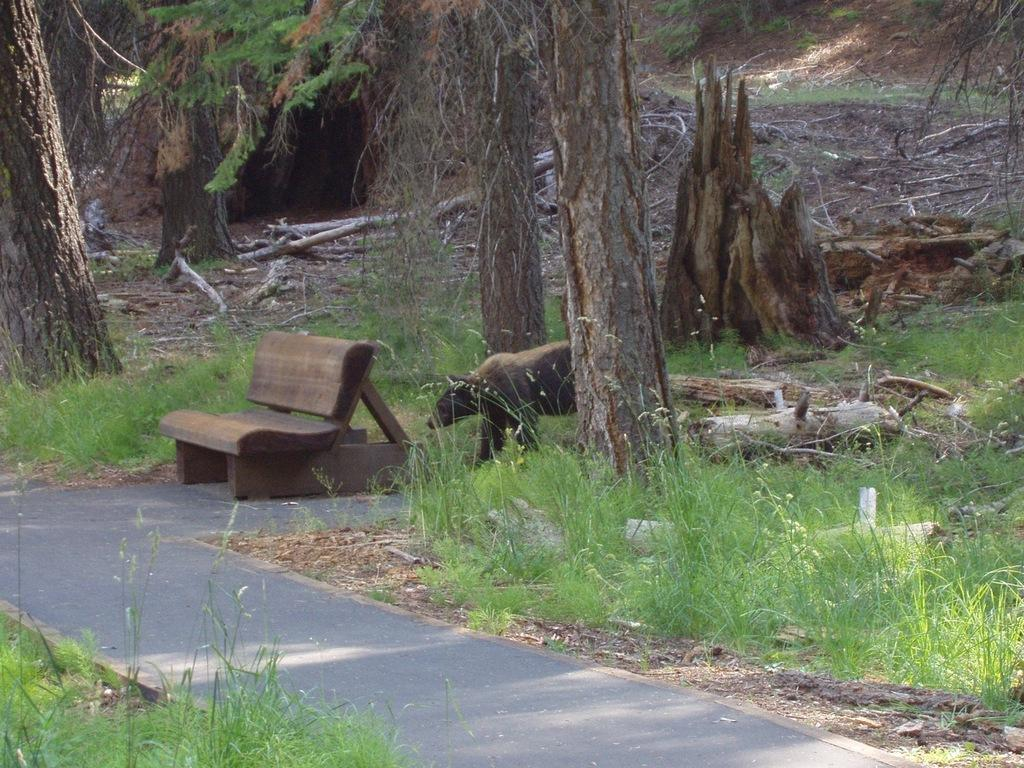What type of animal can be seen in the image? There is an animal in the image, but its specific type is not mentioned in the facts. Where is the animal located in the image? The animal is on grass land. What other features can be seen in the grass land? There are trees and wooden trunks in the grass land. What type of seating is present in the image? There is a bench on a path in the image. What hobbies does the zephyr enjoy while floating above the grass land in the image? There is no mention of a zephyr or any hobbies in the image. A zephyr is a gentle breeze, and it does not have hobbies. 